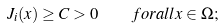<formula> <loc_0><loc_0><loc_500><loc_500>J _ { i } ( x ) \geq C > 0 \quad f o r a l l x \in \Omega ;</formula> 